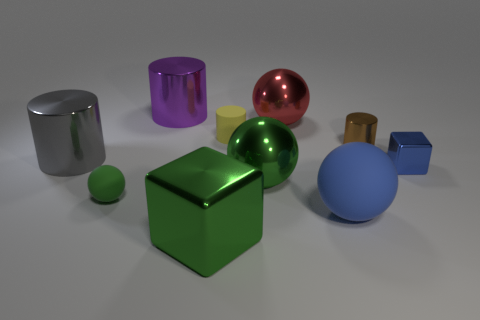What number of shiny spheres are left of the metallic cube that is in front of the shiny block to the right of the big green shiny sphere? 0 